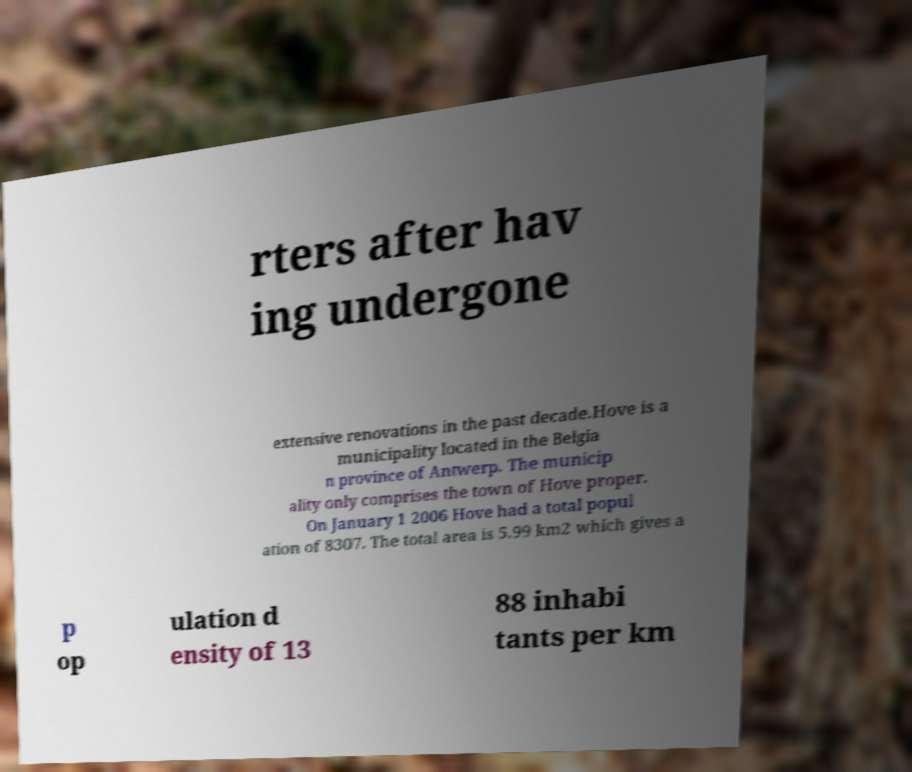Could you assist in decoding the text presented in this image and type it out clearly? rters after hav ing undergone extensive renovations in the past decade.Hove is a municipality located in the Belgia n province of Antwerp. The municip ality only comprises the town of Hove proper. On January 1 2006 Hove had a total popul ation of 8307. The total area is 5.99 km2 which gives a p op ulation d ensity of 13 88 inhabi tants per km 